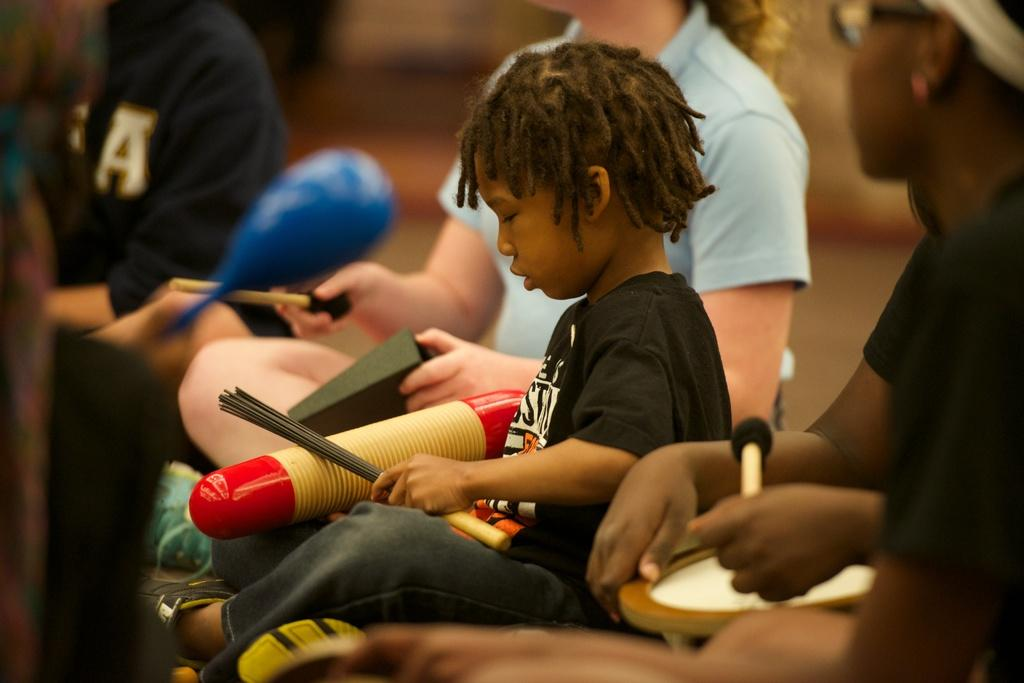What is the general activity of the people in the image? There is a group of people sitting in the image. Can you describe the clothing of the person in front? The person in front is wearing a black shirt and gray pants. What color and pattern can be seen on the object the person in front is holding? The object the person in front is holding is red and cream in color. What type of texture can be seen on the fowl in the image? There is no fowl present in the image. How does the person in front feel about the object they are holding? The image does not provide information about the person's feelings or emotions, so we cannot determine how they feel about the object they are holding. 